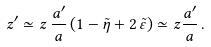<formula> <loc_0><loc_0><loc_500><loc_500>z ^ { \prime } \simeq z \, \frac { a ^ { \prime } } { a } \left ( 1 - \tilde { \eta } + 2 \, \tilde { \varepsilon } \right ) \simeq z \frac { a ^ { \prime } } { a } \, .</formula> 